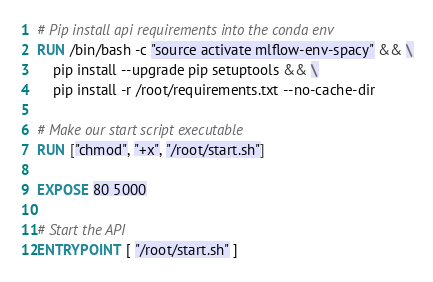Convert code to text. <code><loc_0><loc_0><loc_500><loc_500><_Dockerfile_># Pip install api requirements into the conda env
RUN /bin/bash -c "source activate mlflow-env-spacy" && \
	pip install --upgrade pip setuptools && \
	pip install -r /root/requirements.txt --no-cache-dir

# Make our start script executable
RUN ["chmod", "+x", "/root/start.sh"]

EXPOSE 80 5000

# Start the API
ENTRYPOINT [ "/root/start.sh" ]
</code> 